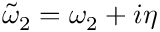Convert formula to latex. <formula><loc_0><loc_0><loc_500><loc_500>\tilde { \omega } _ { 2 } = \omega _ { 2 } + i \eta</formula> 